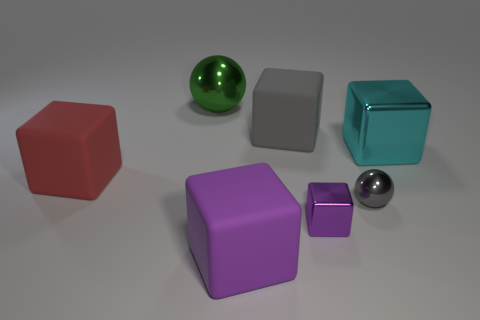What kind of material do the objects seem to be made of? The objects in the image appear to have different textures and finishes. The cubes have a matte finish suggesting they could be made of a material similar to plastic or painted wood. The two spheres, however, reflect light and showcase highlights, indicating that they are likely made of a polished, reflective material like metal or glass.  Do the objects suggest any specific use or purpose? The objects don't seem to have a specific function and appear to be geometric shapes perhaps used for a visual composition or a study in shape, color, and lighting. Their arrangement and simplicity give the impression that they could be used for educational purposes or as part of a 3D modeling and rendering exercise. 